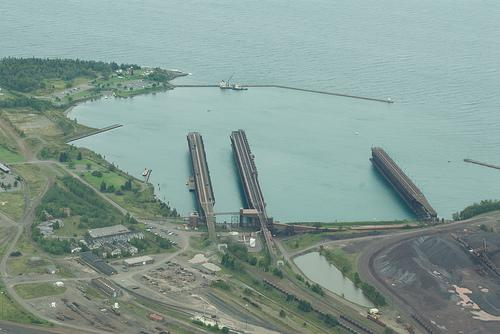Question: what is grey?
Choices:
A. The sky.
B. The water.
C. Roadq.
D. The shirt.
Answer with the letter. Answer: C Question: what is green?
Choices:
A. Grass.
B. Roof.
C. Car.
D. Building.
Answer with the letter. Answer: A Question: what is blue?
Choices:
A. The sky.
B. Water.
C. The car.
D. The school colors.
Answer with the letter. Answer: B 